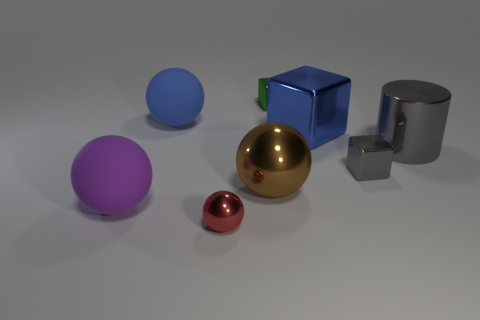Subtract all tiny shiny blocks. How many blocks are left? 1 Subtract all gray cubes. How many cubes are left? 2 Subtract all cylinders. How many objects are left? 7 Subtract all gray cylinders. How many blue balls are left? 1 Add 1 big gray metallic balls. How many objects exist? 9 Subtract 0 red cylinders. How many objects are left? 8 Subtract 2 cubes. How many cubes are left? 1 Subtract all blue cylinders. Subtract all purple blocks. How many cylinders are left? 1 Subtract all blue objects. Subtract all tiny green shiny blocks. How many objects are left? 5 Add 8 large blue cubes. How many large blue cubes are left? 9 